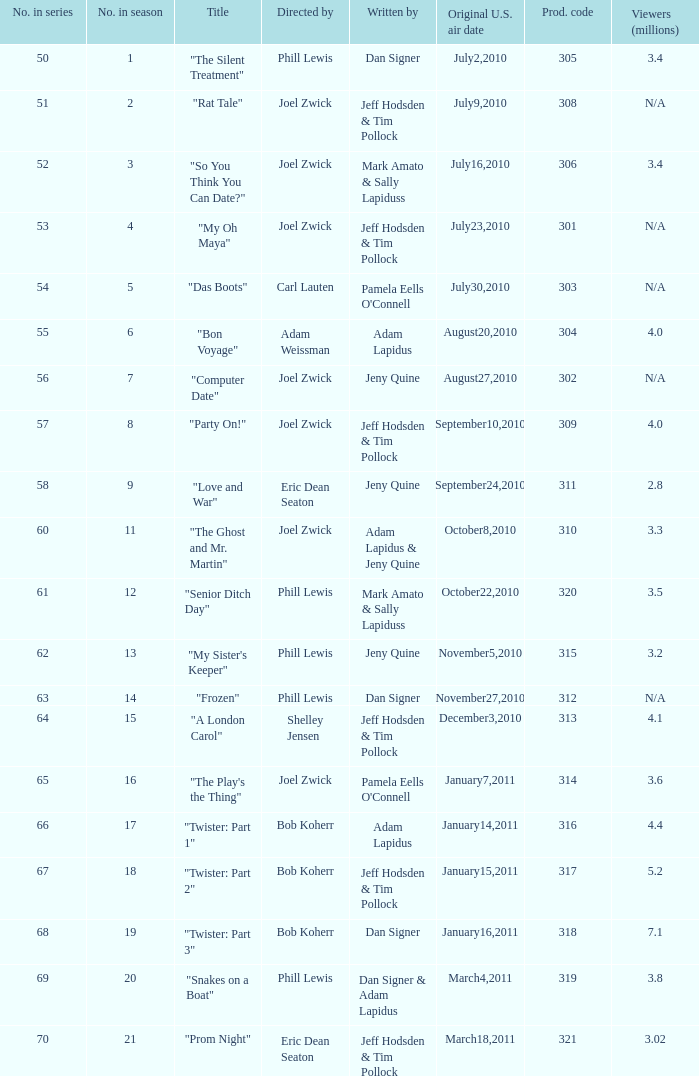Which us broadcast date had January14,2011. 